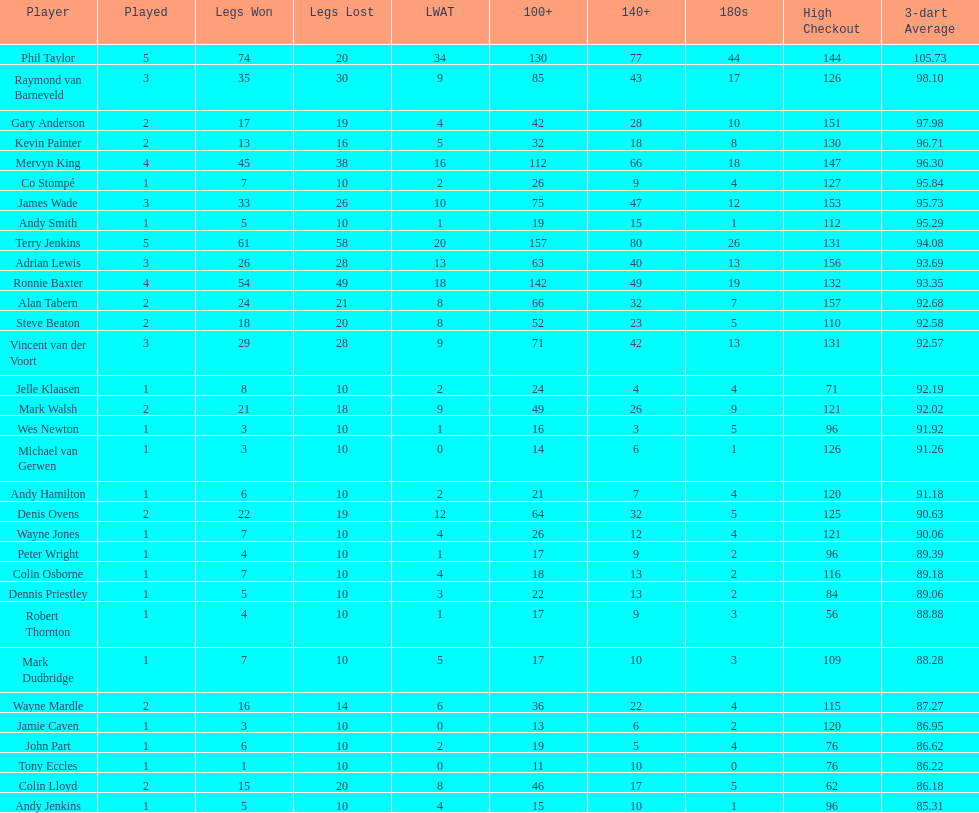How many legs has james wade lost? 26. 